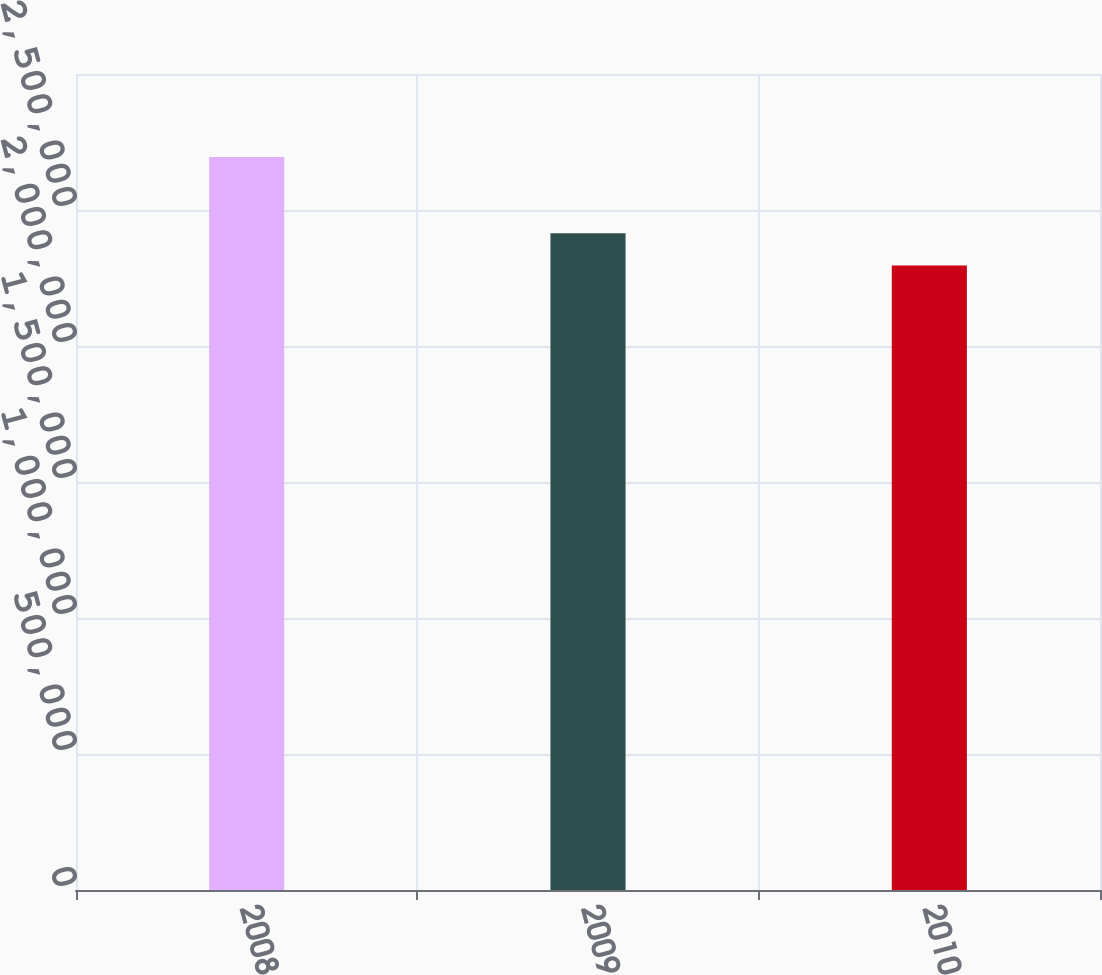Convert chart to OTSL. <chart><loc_0><loc_0><loc_500><loc_500><bar_chart><fcel>2008<fcel>2009<fcel>2010<nl><fcel>2.6946e+06<fcel>2.41482e+06<fcel>2.29621e+06<nl></chart> 